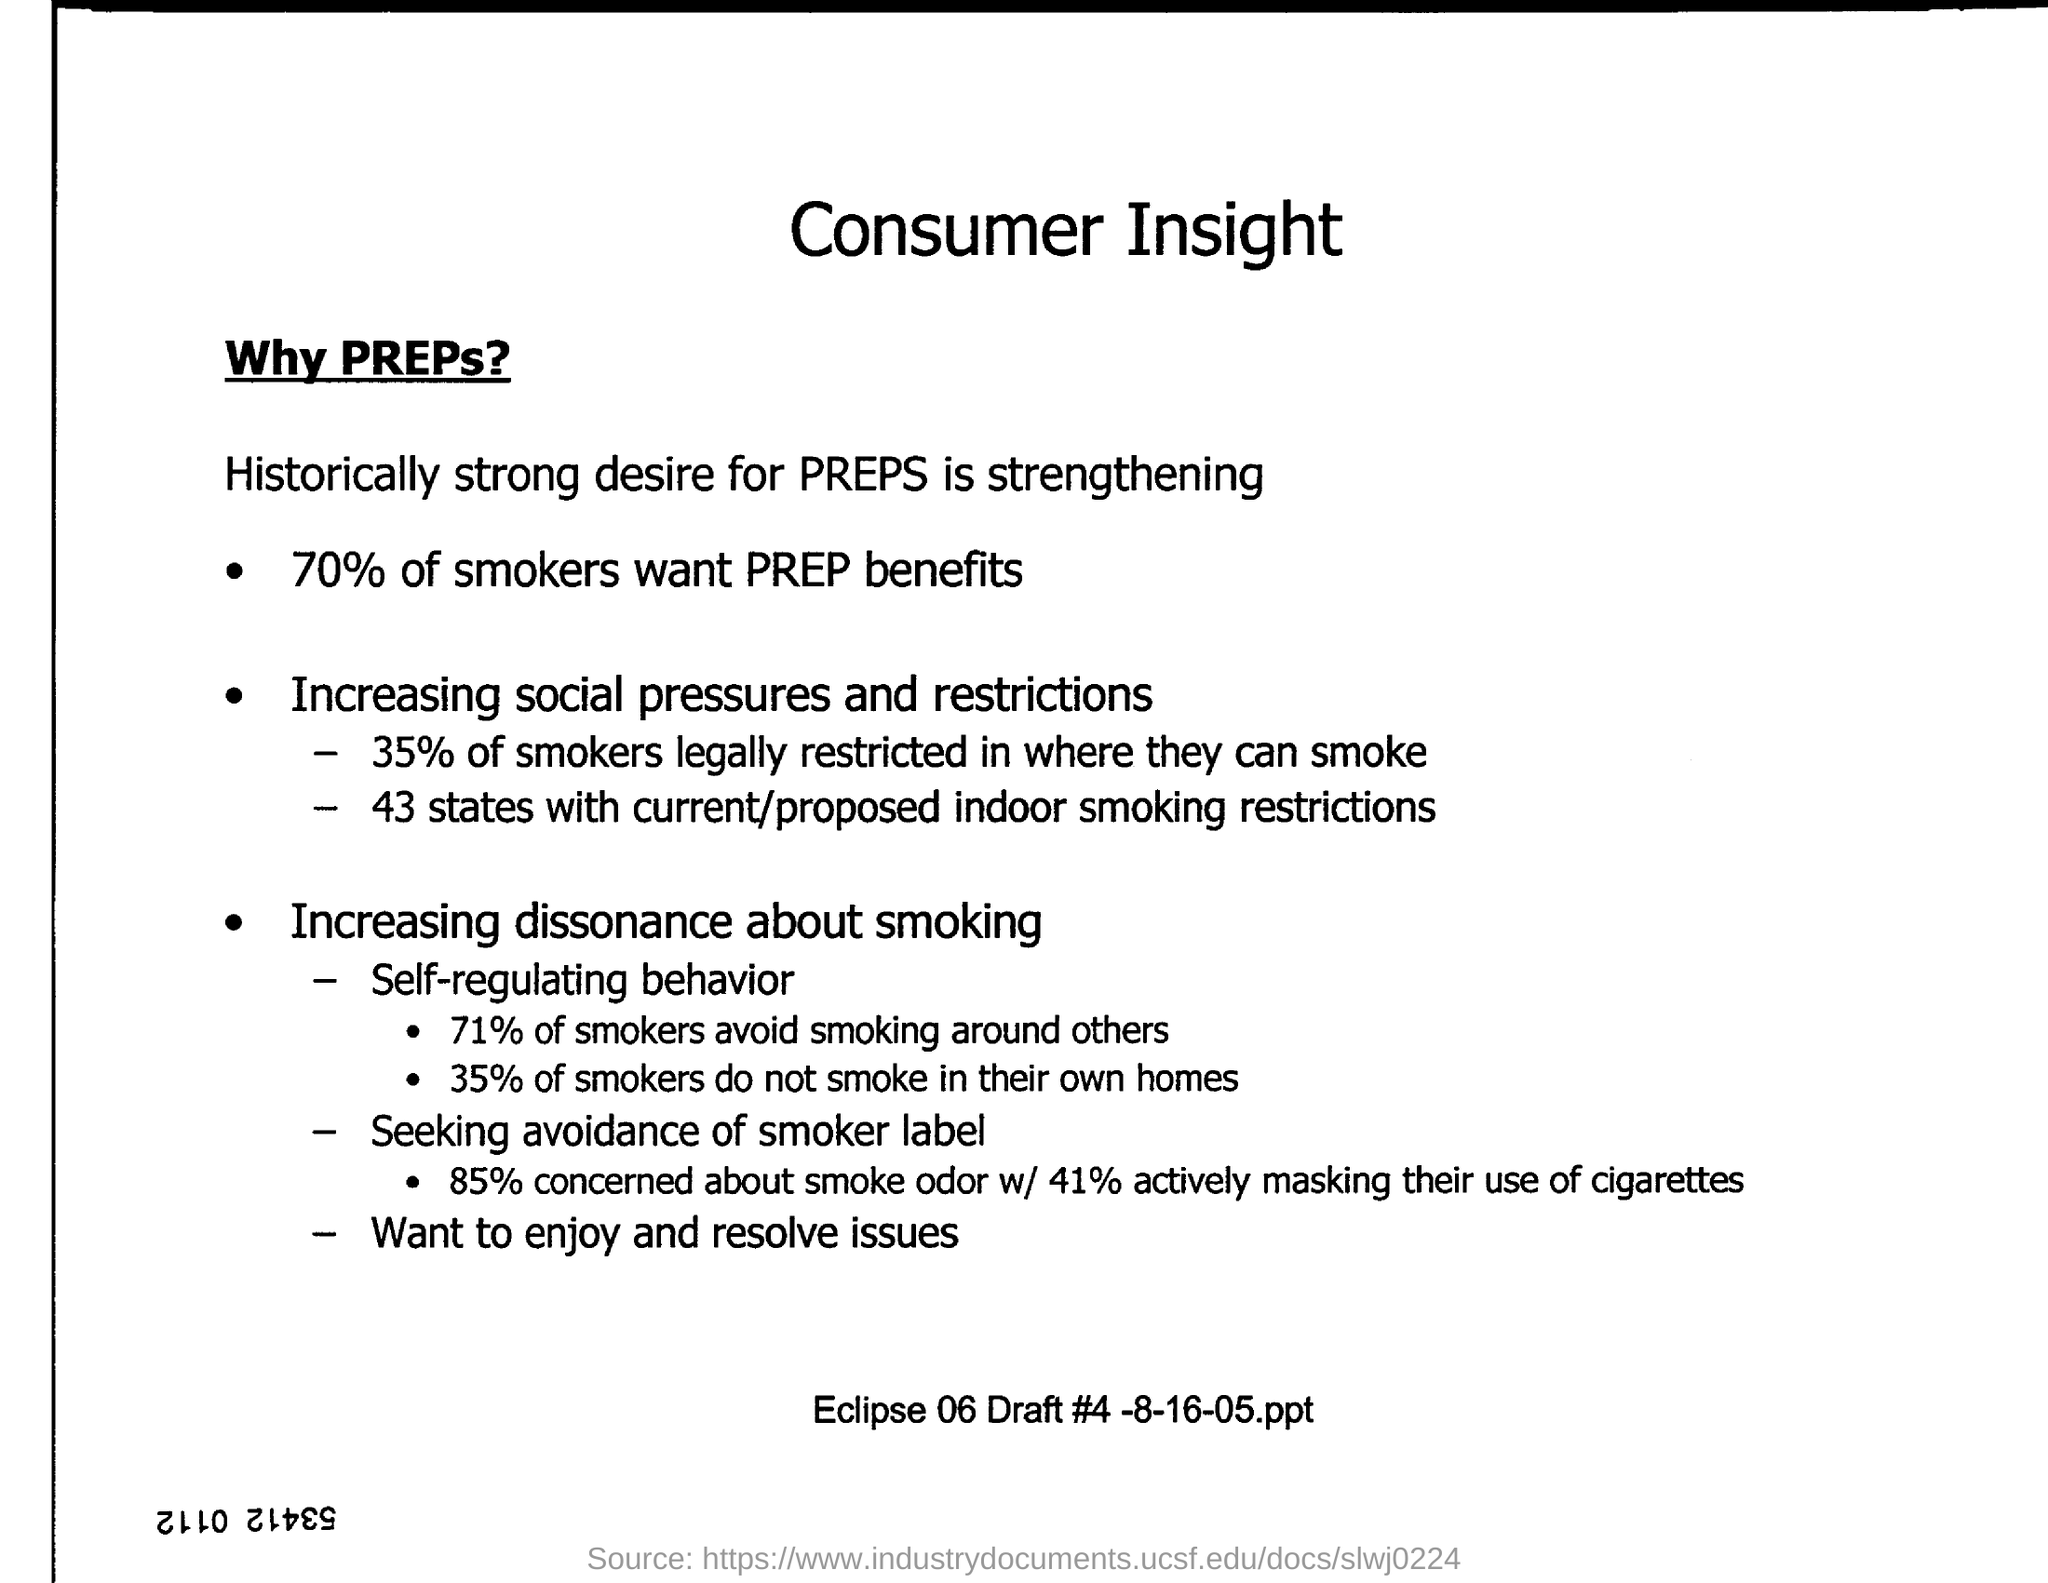Mention a couple of crucial points in this snapshot. Forty-three states have current or proposed indoor smoking restrictions in place. According to a recent study, 41% of smokers actively conceal their cigarette use. According to a recent survey, approximately 35% of smokers do not smoke in their own homes. The main heading of the document is "Consumer Insight". Seventy percent of smokers want to receive PREP benefits. 